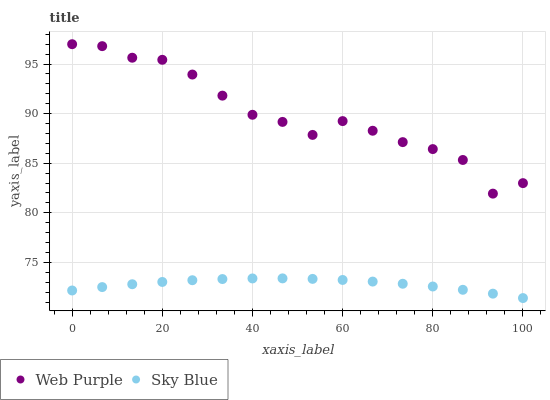Does Sky Blue have the minimum area under the curve?
Answer yes or no. Yes. Does Web Purple have the maximum area under the curve?
Answer yes or no. Yes. Does Web Purple have the minimum area under the curve?
Answer yes or no. No. Is Sky Blue the smoothest?
Answer yes or no. Yes. Is Web Purple the roughest?
Answer yes or no. Yes. Is Web Purple the smoothest?
Answer yes or no. No. Does Sky Blue have the lowest value?
Answer yes or no. Yes. Does Web Purple have the lowest value?
Answer yes or no. No. Does Web Purple have the highest value?
Answer yes or no. Yes. Is Sky Blue less than Web Purple?
Answer yes or no. Yes. Is Web Purple greater than Sky Blue?
Answer yes or no. Yes. Does Sky Blue intersect Web Purple?
Answer yes or no. No. 